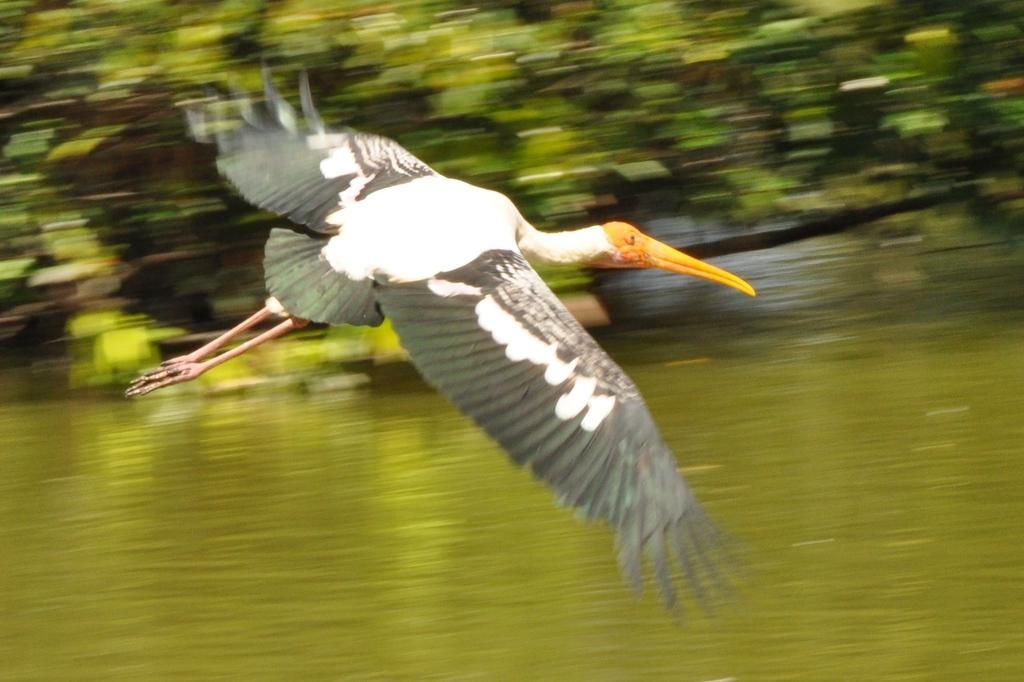Describe this image in one or two sentences. In this picture I can see water. I can see bird flying. I can see trees in the background. 